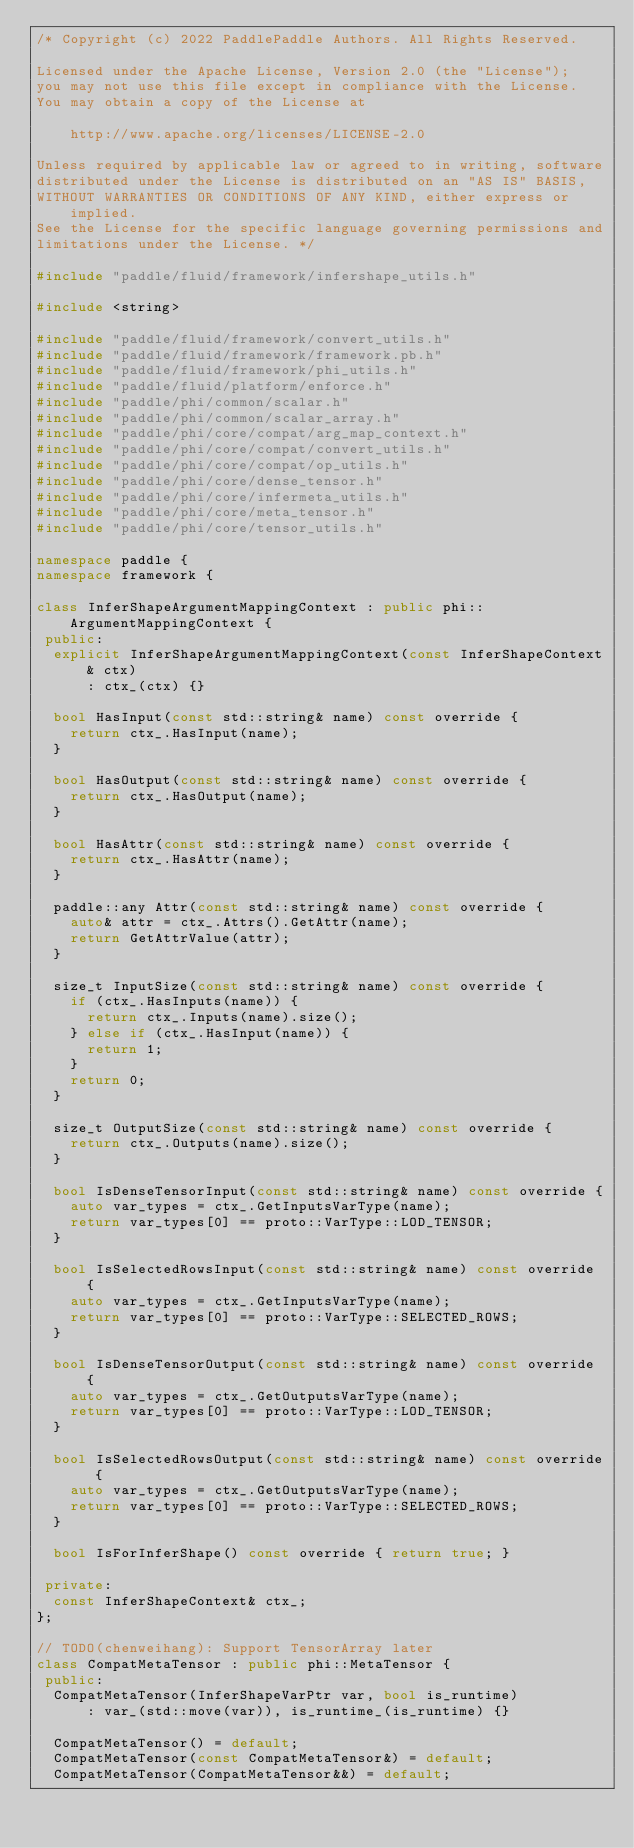Convert code to text. <code><loc_0><loc_0><loc_500><loc_500><_C++_>/* Copyright (c) 2022 PaddlePaddle Authors. All Rights Reserved.

Licensed under the Apache License, Version 2.0 (the "License");
you may not use this file except in compliance with the License.
You may obtain a copy of the License at

    http://www.apache.org/licenses/LICENSE-2.0

Unless required by applicable law or agreed to in writing, software
distributed under the License is distributed on an "AS IS" BASIS,
WITHOUT WARRANTIES OR CONDITIONS OF ANY KIND, either express or implied.
See the License for the specific language governing permissions and
limitations under the License. */

#include "paddle/fluid/framework/infershape_utils.h"

#include <string>

#include "paddle/fluid/framework/convert_utils.h"
#include "paddle/fluid/framework/framework.pb.h"
#include "paddle/fluid/framework/phi_utils.h"
#include "paddle/fluid/platform/enforce.h"
#include "paddle/phi/common/scalar.h"
#include "paddle/phi/common/scalar_array.h"
#include "paddle/phi/core/compat/arg_map_context.h"
#include "paddle/phi/core/compat/convert_utils.h"
#include "paddle/phi/core/compat/op_utils.h"
#include "paddle/phi/core/dense_tensor.h"
#include "paddle/phi/core/infermeta_utils.h"
#include "paddle/phi/core/meta_tensor.h"
#include "paddle/phi/core/tensor_utils.h"

namespace paddle {
namespace framework {

class InferShapeArgumentMappingContext : public phi::ArgumentMappingContext {
 public:
  explicit InferShapeArgumentMappingContext(const InferShapeContext& ctx)
      : ctx_(ctx) {}

  bool HasInput(const std::string& name) const override {
    return ctx_.HasInput(name);
  }

  bool HasOutput(const std::string& name) const override {
    return ctx_.HasOutput(name);
  }

  bool HasAttr(const std::string& name) const override {
    return ctx_.HasAttr(name);
  }

  paddle::any Attr(const std::string& name) const override {
    auto& attr = ctx_.Attrs().GetAttr(name);
    return GetAttrValue(attr);
  }

  size_t InputSize(const std::string& name) const override {
    if (ctx_.HasInputs(name)) {
      return ctx_.Inputs(name).size();
    } else if (ctx_.HasInput(name)) {
      return 1;
    }
    return 0;
  }

  size_t OutputSize(const std::string& name) const override {
    return ctx_.Outputs(name).size();
  }

  bool IsDenseTensorInput(const std::string& name) const override {
    auto var_types = ctx_.GetInputsVarType(name);
    return var_types[0] == proto::VarType::LOD_TENSOR;
  }

  bool IsSelectedRowsInput(const std::string& name) const override {
    auto var_types = ctx_.GetInputsVarType(name);
    return var_types[0] == proto::VarType::SELECTED_ROWS;
  }

  bool IsDenseTensorOutput(const std::string& name) const override {
    auto var_types = ctx_.GetOutputsVarType(name);
    return var_types[0] == proto::VarType::LOD_TENSOR;
  }

  bool IsSelectedRowsOutput(const std::string& name) const override {
    auto var_types = ctx_.GetOutputsVarType(name);
    return var_types[0] == proto::VarType::SELECTED_ROWS;
  }

  bool IsForInferShape() const override { return true; }

 private:
  const InferShapeContext& ctx_;
};

// TODO(chenweihang): Support TensorArray later
class CompatMetaTensor : public phi::MetaTensor {
 public:
  CompatMetaTensor(InferShapeVarPtr var, bool is_runtime)
      : var_(std::move(var)), is_runtime_(is_runtime) {}

  CompatMetaTensor() = default;
  CompatMetaTensor(const CompatMetaTensor&) = default;
  CompatMetaTensor(CompatMetaTensor&&) = default;</code> 